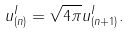<formula> <loc_0><loc_0><loc_500><loc_500>u ^ { I } _ { ( n ) } = \sqrt { 4 \pi } u ^ { I } _ { ( n + 1 ) } .</formula> 